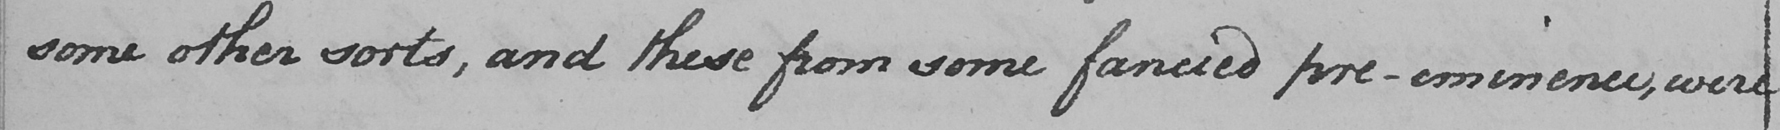Please transcribe the handwritten text in this image. some other sorts , and these from some fancied pre-eminence , were 